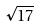Convert formula to latex. <formula><loc_0><loc_0><loc_500><loc_500>\sqrt { 1 7 }</formula> 